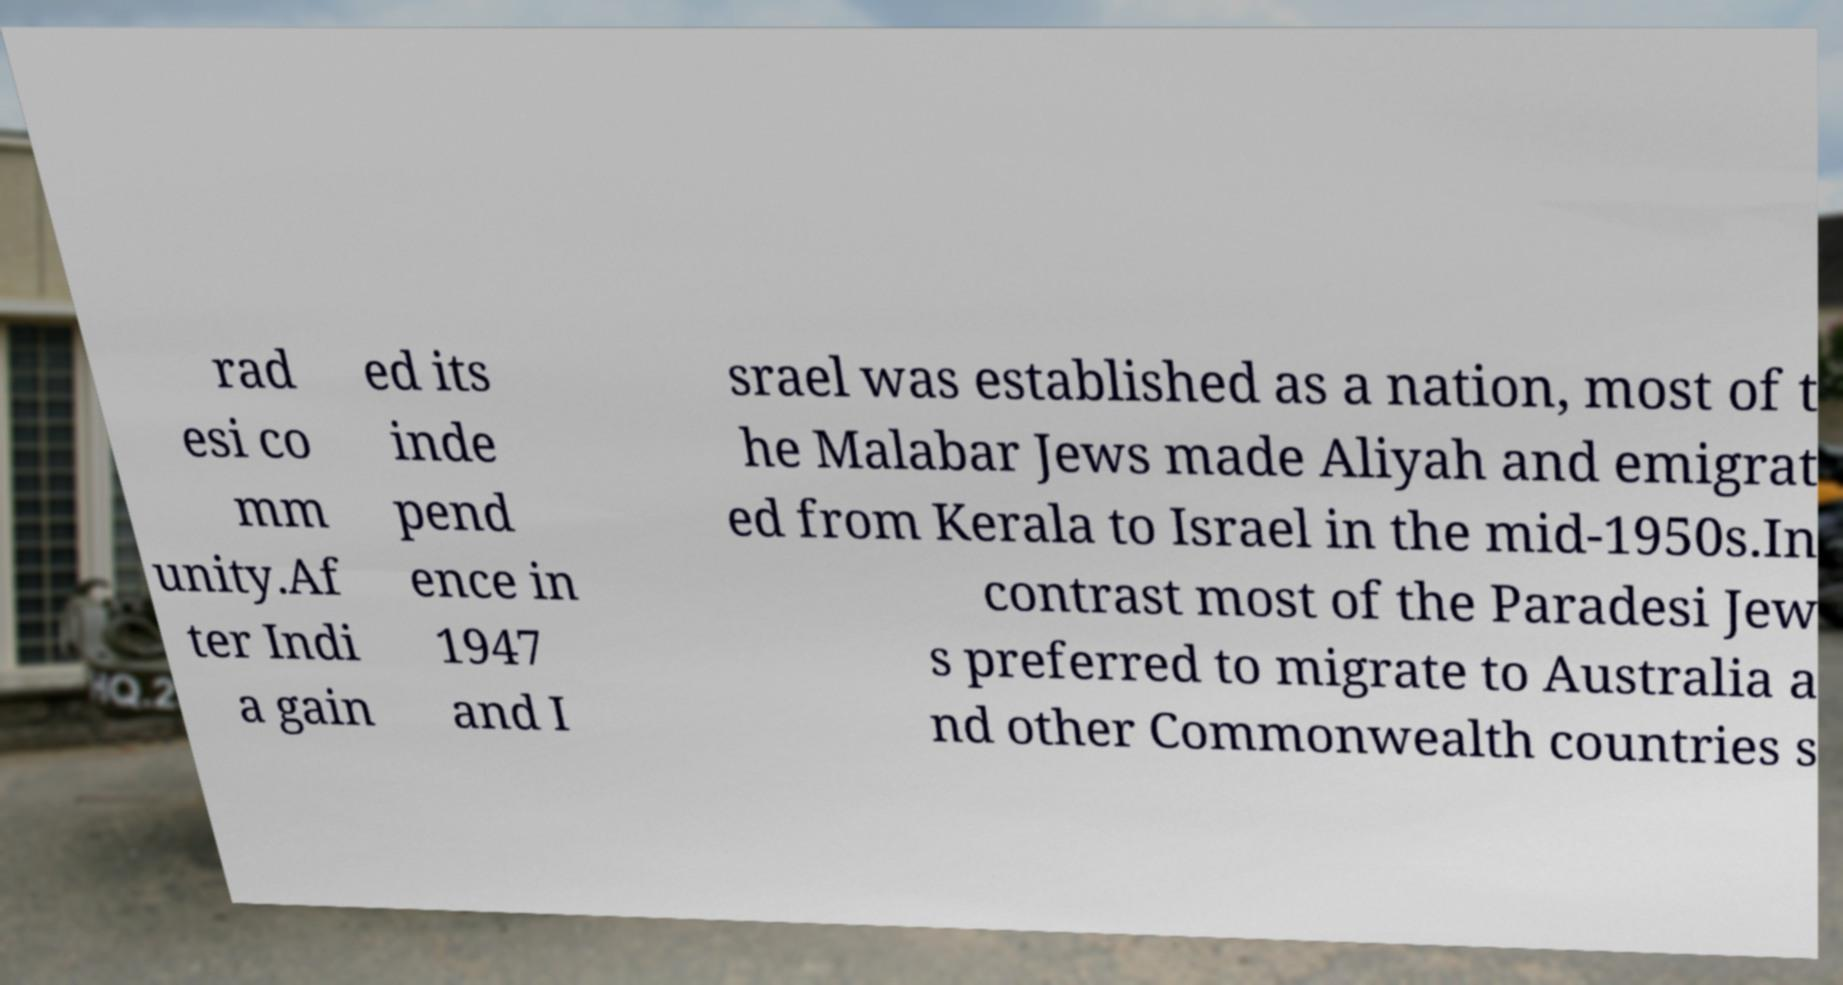There's text embedded in this image that I need extracted. Can you transcribe it verbatim? rad esi co mm unity.Af ter Indi a gain ed its inde pend ence in 1947 and I srael was established as a nation, most of t he Malabar Jews made Aliyah and emigrat ed from Kerala to Israel in the mid-1950s.In contrast most of the Paradesi Jew s preferred to migrate to Australia a nd other Commonwealth countries s 